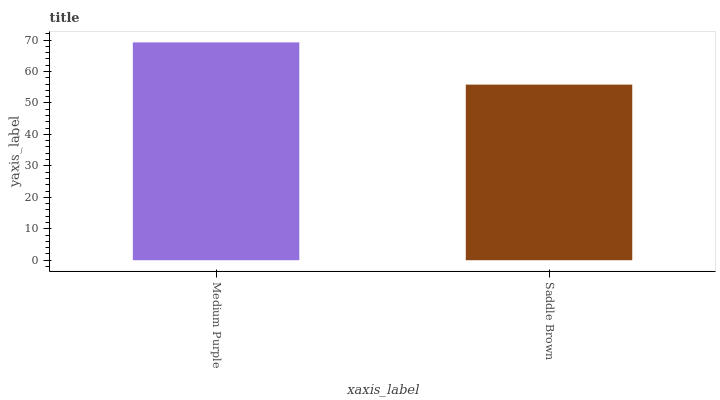Is Saddle Brown the minimum?
Answer yes or no. Yes. Is Medium Purple the maximum?
Answer yes or no. Yes. Is Saddle Brown the maximum?
Answer yes or no. No. Is Medium Purple greater than Saddle Brown?
Answer yes or no. Yes. Is Saddle Brown less than Medium Purple?
Answer yes or no. Yes. Is Saddle Brown greater than Medium Purple?
Answer yes or no. No. Is Medium Purple less than Saddle Brown?
Answer yes or no. No. Is Medium Purple the high median?
Answer yes or no. Yes. Is Saddle Brown the low median?
Answer yes or no. Yes. Is Saddle Brown the high median?
Answer yes or no. No. Is Medium Purple the low median?
Answer yes or no. No. 